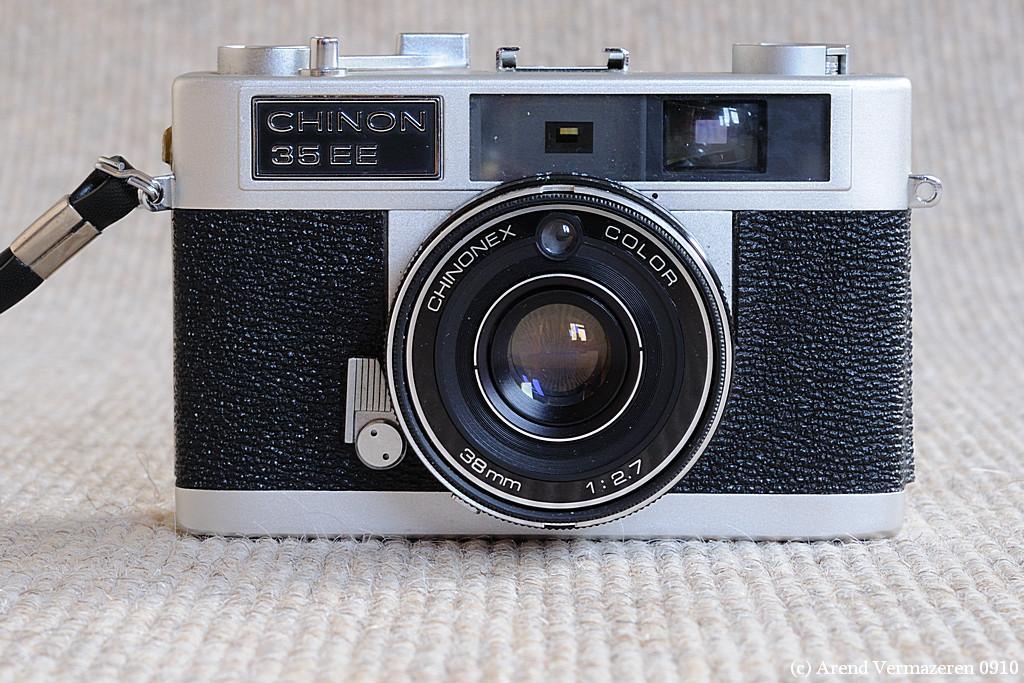How would you summarize this image in a sentence or two? This is a zoomed in picture. In the center there is a camera placed on a white color object. We can see the text on the camera and the different parts and a button of a camera. At the bottom right corner there is a watermark on the image. 